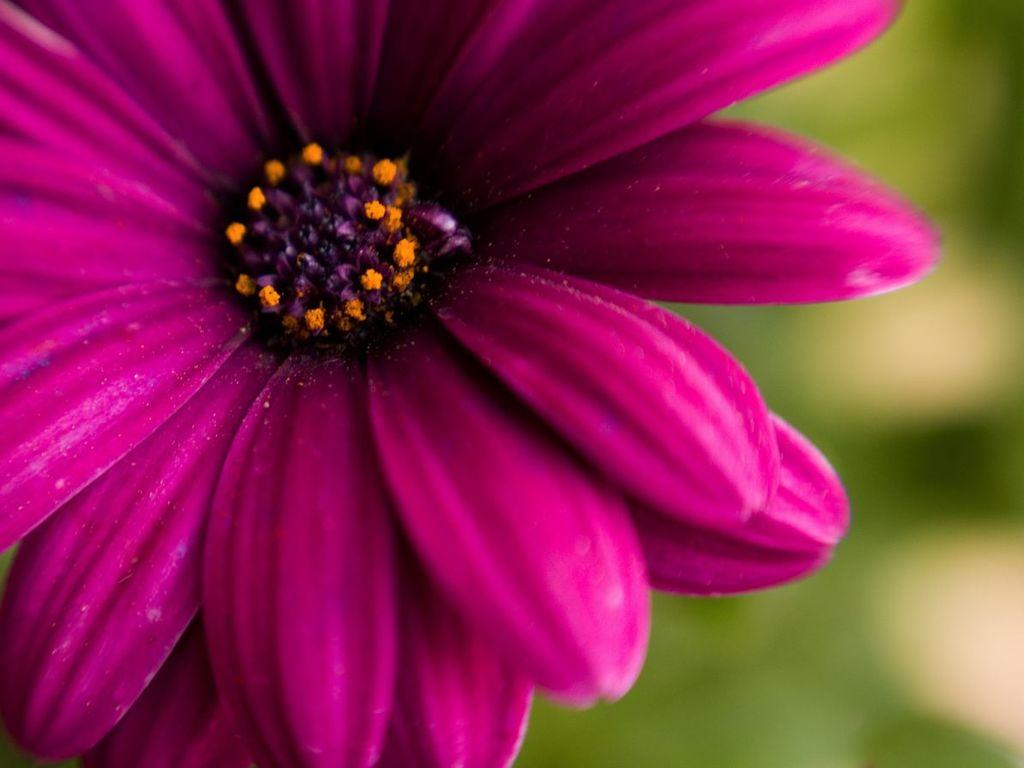What is the main subject in the foreground of the image? There is a flower in the foreground of the image. What can be observed about the background of the image? The background of the image is blurry. What type of twig can be seen in the image? There is no twig present in the image. What scene is depicted in the image? The image only shows a flower in the foreground and a blurry background, so it cannot be described as a specific scene. 